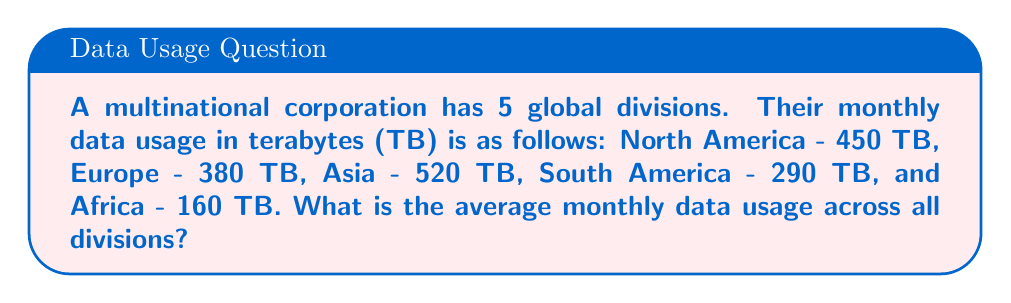Solve this math problem. To find the average monthly data usage across all divisions, we need to:

1. Sum up the total data usage:
   $$450 + 380 + 520 + 290 + 160 = 1800\text{ TB}$$

2. Count the number of divisions:
   There are 5 divisions.

3. Calculate the average by dividing the total by the number of divisions:
   $$\text{Average} = \frac{\text{Total data usage}}{\text{Number of divisions}} = \frac{1800}{5} = 360\text{ TB}$$

Therefore, the average monthly data usage across all divisions is 360 TB.
Answer: 360 TB 